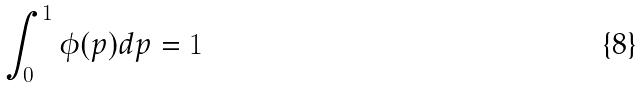<formula> <loc_0><loc_0><loc_500><loc_500>\int _ { 0 } ^ { 1 } \phi ( p ) d p = 1</formula> 